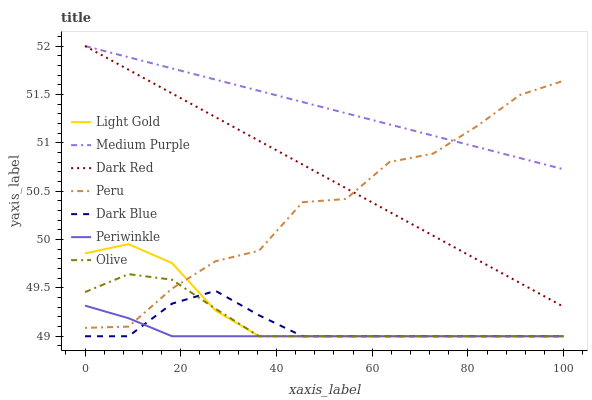Does Periwinkle have the minimum area under the curve?
Answer yes or no. Yes. Does Medium Purple have the maximum area under the curve?
Answer yes or no. Yes. Does Dark Blue have the minimum area under the curve?
Answer yes or no. No. Does Dark Blue have the maximum area under the curve?
Answer yes or no. No. Is Dark Red the smoothest?
Answer yes or no. Yes. Is Peru the roughest?
Answer yes or no. Yes. Is Medium Purple the smoothest?
Answer yes or no. No. Is Medium Purple the roughest?
Answer yes or no. No. Does Dark Blue have the lowest value?
Answer yes or no. Yes. Does Medium Purple have the lowest value?
Answer yes or no. No. Does Medium Purple have the highest value?
Answer yes or no. Yes. Does Dark Blue have the highest value?
Answer yes or no. No. Is Dark Blue less than Dark Red?
Answer yes or no. Yes. Is Dark Red greater than Light Gold?
Answer yes or no. Yes. Does Dark Red intersect Peru?
Answer yes or no. Yes. Is Dark Red less than Peru?
Answer yes or no. No. Is Dark Red greater than Peru?
Answer yes or no. No. Does Dark Blue intersect Dark Red?
Answer yes or no. No. 